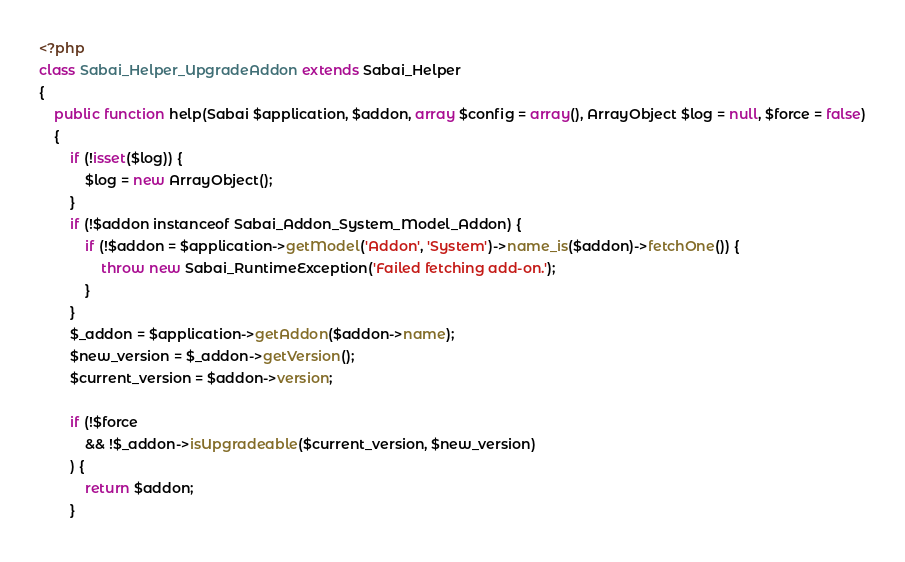Convert code to text. <code><loc_0><loc_0><loc_500><loc_500><_PHP_><?php
class Sabai_Helper_UpgradeAddon extends Sabai_Helper
{
    public function help(Sabai $application, $addon, array $config = array(), ArrayObject $log = null, $force = false)
    {
        if (!isset($log)) {
            $log = new ArrayObject();
        }
        if (!$addon instanceof Sabai_Addon_System_Model_Addon) {
            if (!$addon = $application->getModel('Addon', 'System')->name_is($addon)->fetchOne()) {
                throw new Sabai_RuntimeException('Failed fetching add-on.');
            }
        }
        $_addon = $application->getAddon($addon->name);
        $new_version = $_addon->getVersion();
        $current_version = $addon->version;
        
        if (!$force
            && !$_addon->isUpgradeable($current_version, $new_version)
        ) {
            return $addon;
        }
</code> 